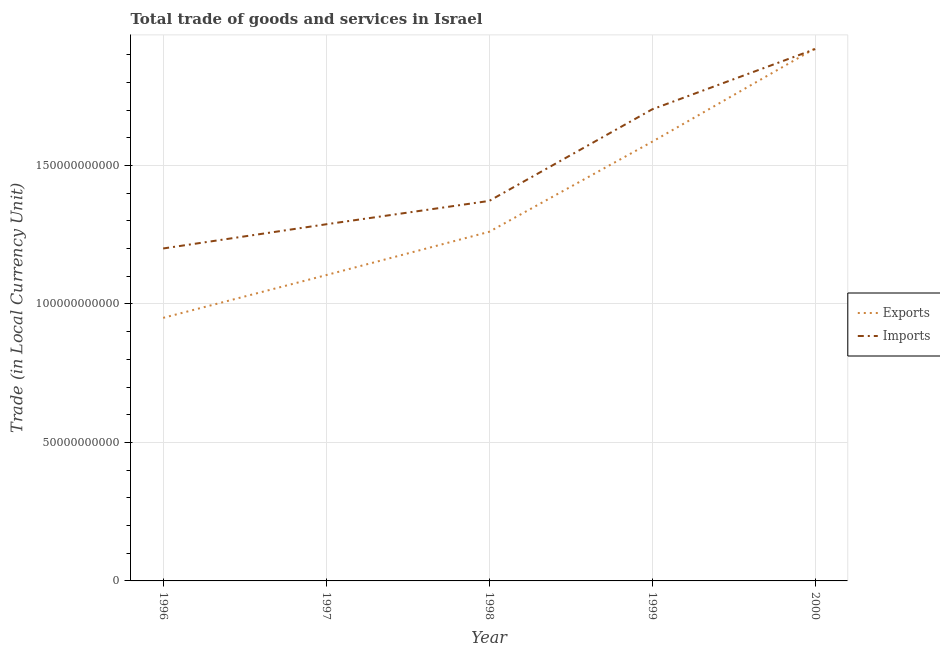How many different coloured lines are there?
Provide a short and direct response. 2. Does the line corresponding to export of goods and services intersect with the line corresponding to imports of goods and services?
Offer a terse response. Yes. Is the number of lines equal to the number of legend labels?
Provide a succinct answer. Yes. What is the imports of goods and services in 1996?
Make the answer very short. 1.20e+11. Across all years, what is the maximum imports of goods and services?
Your response must be concise. 1.92e+11. Across all years, what is the minimum imports of goods and services?
Your answer should be compact. 1.20e+11. In which year was the imports of goods and services minimum?
Ensure brevity in your answer.  1996. What is the total export of goods and services in the graph?
Provide a short and direct response. 6.82e+11. What is the difference between the export of goods and services in 1996 and that in 1997?
Provide a short and direct response. -1.54e+1. What is the difference between the imports of goods and services in 1997 and the export of goods and services in 2000?
Offer a very short reply. -6.35e+1. What is the average imports of goods and services per year?
Provide a succinct answer. 1.50e+11. In the year 1996, what is the difference between the export of goods and services and imports of goods and services?
Provide a short and direct response. -2.51e+1. In how many years, is the export of goods and services greater than 70000000000 LCU?
Keep it short and to the point. 5. What is the ratio of the imports of goods and services in 1998 to that in 2000?
Your response must be concise. 0.71. Is the imports of goods and services in 1997 less than that in 2000?
Give a very brief answer. Yes. What is the difference between the highest and the second highest imports of goods and services?
Ensure brevity in your answer.  2.18e+1. What is the difference between the highest and the lowest imports of goods and services?
Provide a short and direct response. 7.20e+1. In how many years, is the imports of goods and services greater than the average imports of goods and services taken over all years?
Keep it short and to the point. 2. Is the sum of the imports of goods and services in 1997 and 1998 greater than the maximum export of goods and services across all years?
Offer a very short reply. Yes. Does the graph contain any zero values?
Keep it short and to the point. No. Where does the legend appear in the graph?
Ensure brevity in your answer.  Center right. How many legend labels are there?
Provide a short and direct response. 2. What is the title of the graph?
Give a very brief answer. Total trade of goods and services in Israel. What is the label or title of the Y-axis?
Make the answer very short. Trade (in Local Currency Unit). What is the Trade (in Local Currency Unit) in Exports in 1996?
Ensure brevity in your answer.  9.50e+1. What is the Trade (in Local Currency Unit) in Imports in 1996?
Ensure brevity in your answer.  1.20e+11. What is the Trade (in Local Currency Unit) in Exports in 1997?
Make the answer very short. 1.10e+11. What is the Trade (in Local Currency Unit) of Imports in 1997?
Ensure brevity in your answer.  1.29e+11. What is the Trade (in Local Currency Unit) of Exports in 1998?
Make the answer very short. 1.26e+11. What is the Trade (in Local Currency Unit) of Imports in 1998?
Your response must be concise. 1.37e+11. What is the Trade (in Local Currency Unit) of Exports in 1999?
Your answer should be very brief. 1.59e+11. What is the Trade (in Local Currency Unit) in Imports in 1999?
Your response must be concise. 1.70e+11. What is the Trade (in Local Currency Unit) in Exports in 2000?
Give a very brief answer. 1.92e+11. What is the Trade (in Local Currency Unit) of Imports in 2000?
Your response must be concise. 1.92e+11. Across all years, what is the maximum Trade (in Local Currency Unit) in Exports?
Provide a succinct answer. 1.92e+11. Across all years, what is the maximum Trade (in Local Currency Unit) of Imports?
Your answer should be compact. 1.92e+11. Across all years, what is the minimum Trade (in Local Currency Unit) in Exports?
Your answer should be very brief. 9.50e+1. Across all years, what is the minimum Trade (in Local Currency Unit) of Imports?
Give a very brief answer. 1.20e+11. What is the total Trade (in Local Currency Unit) of Exports in the graph?
Your answer should be very brief. 6.82e+11. What is the total Trade (in Local Currency Unit) in Imports in the graph?
Make the answer very short. 7.48e+11. What is the difference between the Trade (in Local Currency Unit) of Exports in 1996 and that in 1997?
Offer a terse response. -1.54e+1. What is the difference between the Trade (in Local Currency Unit) in Imports in 1996 and that in 1997?
Provide a succinct answer. -8.73e+09. What is the difference between the Trade (in Local Currency Unit) in Exports in 1996 and that in 1998?
Offer a very short reply. -3.11e+1. What is the difference between the Trade (in Local Currency Unit) of Imports in 1996 and that in 1998?
Provide a short and direct response. -1.72e+1. What is the difference between the Trade (in Local Currency Unit) in Exports in 1996 and that in 1999?
Your answer should be compact. -6.36e+1. What is the difference between the Trade (in Local Currency Unit) of Imports in 1996 and that in 1999?
Give a very brief answer. -5.02e+1. What is the difference between the Trade (in Local Currency Unit) in Exports in 1996 and that in 2000?
Provide a succinct answer. -9.73e+1. What is the difference between the Trade (in Local Currency Unit) in Imports in 1996 and that in 2000?
Provide a short and direct response. -7.20e+1. What is the difference between the Trade (in Local Currency Unit) in Exports in 1997 and that in 1998?
Keep it short and to the point. -1.56e+1. What is the difference between the Trade (in Local Currency Unit) of Imports in 1997 and that in 1998?
Your answer should be compact. -8.43e+09. What is the difference between the Trade (in Local Currency Unit) in Exports in 1997 and that in 1999?
Ensure brevity in your answer.  -4.82e+1. What is the difference between the Trade (in Local Currency Unit) of Imports in 1997 and that in 1999?
Keep it short and to the point. -4.15e+1. What is the difference between the Trade (in Local Currency Unit) in Exports in 1997 and that in 2000?
Provide a short and direct response. -8.19e+1. What is the difference between the Trade (in Local Currency Unit) in Imports in 1997 and that in 2000?
Give a very brief answer. -6.33e+1. What is the difference between the Trade (in Local Currency Unit) in Exports in 1998 and that in 1999?
Your answer should be compact. -3.25e+1. What is the difference between the Trade (in Local Currency Unit) of Imports in 1998 and that in 1999?
Give a very brief answer. -3.31e+1. What is the difference between the Trade (in Local Currency Unit) of Exports in 1998 and that in 2000?
Provide a succinct answer. -6.62e+1. What is the difference between the Trade (in Local Currency Unit) in Imports in 1998 and that in 2000?
Offer a very short reply. -5.48e+1. What is the difference between the Trade (in Local Currency Unit) in Exports in 1999 and that in 2000?
Make the answer very short. -3.37e+1. What is the difference between the Trade (in Local Currency Unit) of Imports in 1999 and that in 2000?
Your response must be concise. -2.18e+1. What is the difference between the Trade (in Local Currency Unit) of Exports in 1996 and the Trade (in Local Currency Unit) of Imports in 1997?
Keep it short and to the point. -3.38e+1. What is the difference between the Trade (in Local Currency Unit) of Exports in 1996 and the Trade (in Local Currency Unit) of Imports in 1998?
Offer a very short reply. -4.22e+1. What is the difference between the Trade (in Local Currency Unit) of Exports in 1996 and the Trade (in Local Currency Unit) of Imports in 1999?
Ensure brevity in your answer.  -7.53e+1. What is the difference between the Trade (in Local Currency Unit) in Exports in 1996 and the Trade (in Local Currency Unit) in Imports in 2000?
Offer a very short reply. -9.71e+1. What is the difference between the Trade (in Local Currency Unit) of Exports in 1997 and the Trade (in Local Currency Unit) of Imports in 1998?
Provide a short and direct response. -2.68e+1. What is the difference between the Trade (in Local Currency Unit) of Exports in 1997 and the Trade (in Local Currency Unit) of Imports in 1999?
Offer a very short reply. -5.98e+1. What is the difference between the Trade (in Local Currency Unit) in Exports in 1997 and the Trade (in Local Currency Unit) in Imports in 2000?
Provide a short and direct response. -8.16e+1. What is the difference between the Trade (in Local Currency Unit) of Exports in 1998 and the Trade (in Local Currency Unit) of Imports in 1999?
Give a very brief answer. -4.42e+1. What is the difference between the Trade (in Local Currency Unit) in Exports in 1998 and the Trade (in Local Currency Unit) in Imports in 2000?
Offer a terse response. -6.60e+1. What is the difference between the Trade (in Local Currency Unit) of Exports in 1999 and the Trade (in Local Currency Unit) of Imports in 2000?
Provide a short and direct response. -3.35e+1. What is the average Trade (in Local Currency Unit) in Exports per year?
Your response must be concise. 1.36e+11. What is the average Trade (in Local Currency Unit) of Imports per year?
Your answer should be very brief. 1.50e+11. In the year 1996, what is the difference between the Trade (in Local Currency Unit) in Exports and Trade (in Local Currency Unit) in Imports?
Give a very brief answer. -2.51e+1. In the year 1997, what is the difference between the Trade (in Local Currency Unit) in Exports and Trade (in Local Currency Unit) in Imports?
Your answer should be compact. -1.84e+1. In the year 1998, what is the difference between the Trade (in Local Currency Unit) in Exports and Trade (in Local Currency Unit) in Imports?
Ensure brevity in your answer.  -1.11e+1. In the year 1999, what is the difference between the Trade (in Local Currency Unit) of Exports and Trade (in Local Currency Unit) of Imports?
Keep it short and to the point. -1.17e+1. In the year 2000, what is the difference between the Trade (in Local Currency Unit) in Exports and Trade (in Local Currency Unit) in Imports?
Provide a succinct answer. 2.51e+08. What is the ratio of the Trade (in Local Currency Unit) of Exports in 1996 to that in 1997?
Your answer should be compact. 0.86. What is the ratio of the Trade (in Local Currency Unit) in Imports in 1996 to that in 1997?
Give a very brief answer. 0.93. What is the ratio of the Trade (in Local Currency Unit) in Exports in 1996 to that in 1998?
Offer a very short reply. 0.75. What is the ratio of the Trade (in Local Currency Unit) in Imports in 1996 to that in 1998?
Give a very brief answer. 0.87. What is the ratio of the Trade (in Local Currency Unit) of Exports in 1996 to that in 1999?
Your answer should be very brief. 0.6. What is the ratio of the Trade (in Local Currency Unit) in Imports in 1996 to that in 1999?
Provide a short and direct response. 0.7. What is the ratio of the Trade (in Local Currency Unit) in Exports in 1996 to that in 2000?
Give a very brief answer. 0.49. What is the ratio of the Trade (in Local Currency Unit) in Imports in 1996 to that in 2000?
Your answer should be compact. 0.63. What is the ratio of the Trade (in Local Currency Unit) in Exports in 1997 to that in 1998?
Give a very brief answer. 0.88. What is the ratio of the Trade (in Local Currency Unit) of Imports in 1997 to that in 1998?
Provide a succinct answer. 0.94. What is the ratio of the Trade (in Local Currency Unit) of Exports in 1997 to that in 1999?
Ensure brevity in your answer.  0.7. What is the ratio of the Trade (in Local Currency Unit) in Imports in 1997 to that in 1999?
Ensure brevity in your answer.  0.76. What is the ratio of the Trade (in Local Currency Unit) of Exports in 1997 to that in 2000?
Your answer should be compact. 0.57. What is the ratio of the Trade (in Local Currency Unit) in Imports in 1997 to that in 2000?
Provide a short and direct response. 0.67. What is the ratio of the Trade (in Local Currency Unit) of Exports in 1998 to that in 1999?
Your answer should be very brief. 0.79. What is the ratio of the Trade (in Local Currency Unit) in Imports in 1998 to that in 1999?
Ensure brevity in your answer.  0.81. What is the ratio of the Trade (in Local Currency Unit) of Exports in 1998 to that in 2000?
Ensure brevity in your answer.  0.66. What is the ratio of the Trade (in Local Currency Unit) of Imports in 1998 to that in 2000?
Make the answer very short. 0.71. What is the ratio of the Trade (in Local Currency Unit) in Exports in 1999 to that in 2000?
Provide a succinct answer. 0.82. What is the ratio of the Trade (in Local Currency Unit) of Imports in 1999 to that in 2000?
Your response must be concise. 0.89. What is the difference between the highest and the second highest Trade (in Local Currency Unit) of Exports?
Ensure brevity in your answer.  3.37e+1. What is the difference between the highest and the second highest Trade (in Local Currency Unit) of Imports?
Provide a succinct answer. 2.18e+1. What is the difference between the highest and the lowest Trade (in Local Currency Unit) of Exports?
Your answer should be very brief. 9.73e+1. What is the difference between the highest and the lowest Trade (in Local Currency Unit) of Imports?
Your response must be concise. 7.20e+1. 